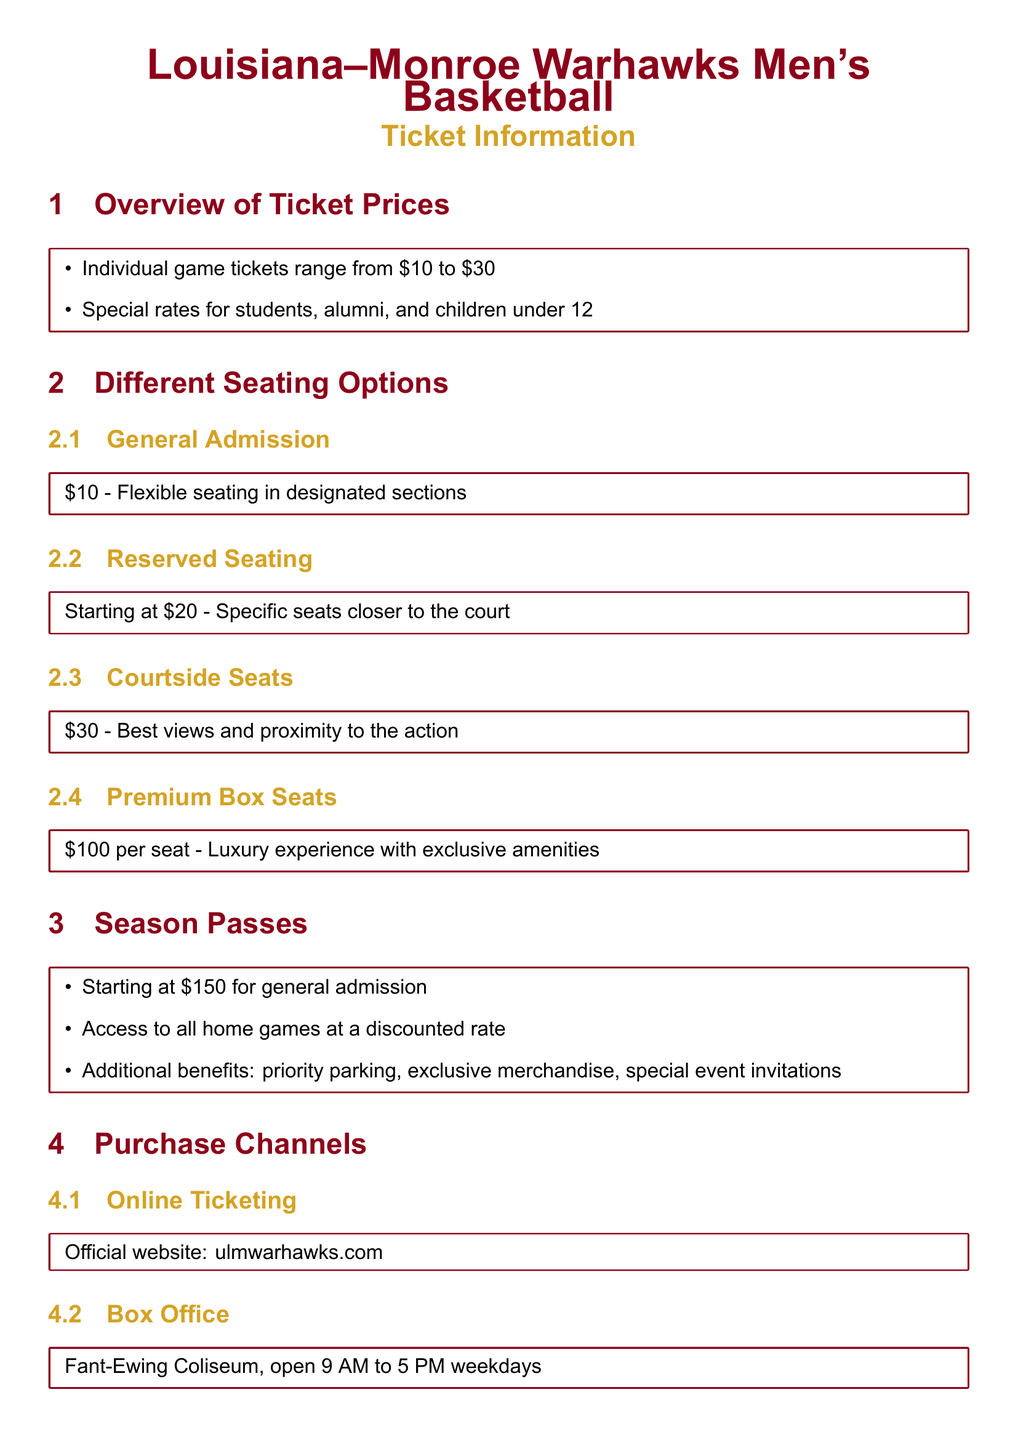what is the price range for individual game tickets? The price range for individual game tickets is mentioned in the Overview section, ranging from $10 to $30.
Answer: $10 to $30 how much do courtside seats cost? Courtside seats are specifically listed under Different Seating Options, priced at $30.
Answer: $30 what is the cost for premium box seats? The cost for premium box seats is explicitly stated as $100 per seat.
Answer: $100 per seat what additional benefits come with season passes? The benefits of season passes include priority parking, exclusive merchandise, and special event invitations, as detailed in the Season Passes section.
Answer: priority parking, exclusive merchandise, special event invitations where can tickets be purchased online? The document indicates that tickets can be purchased online from the official website, which is ulmwarhawks.com.
Answer: ulmwarhawks.com how much does a general admission season pass start at? The starting price for a general admission season pass is mentioned in the Season Passes section.
Answer: $150 what time does the box office open? The opening time for the box office is set in the Purchase Channels section, highlighting weekdays and specific hours.
Answer: 9 AM what is the benefit of reserved seating compared to general admission? The reasoning behind the benefits of reserved seating involves having specific seats closer to the court as opposed to flexible seating in designated sections.
Answer: specific seats closer to the court what is the name of the app for mobile ticket purchases? The document specifies that the official app for mobile purchases is the Official Warhawks app, available for both iOS and Android.
Answer: Official Warhawks app 